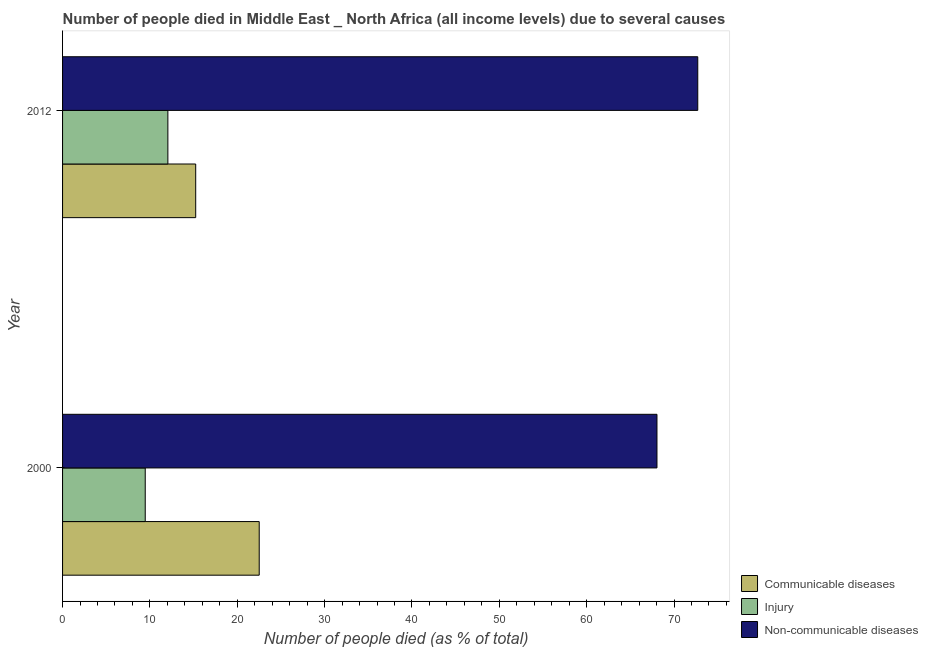How many groups of bars are there?
Make the answer very short. 2. How many bars are there on the 2nd tick from the top?
Offer a very short reply. 3. In how many cases, is the number of bars for a given year not equal to the number of legend labels?
Provide a succinct answer. 0. What is the number of people who died of communicable diseases in 2012?
Ensure brevity in your answer.  15.24. Across all years, what is the maximum number of people who dies of non-communicable diseases?
Keep it short and to the point. 72.72. Across all years, what is the minimum number of people who dies of non-communicable diseases?
Provide a succinct answer. 68.05. In which year was the number of people who dies of non-communicable diseases maximum?
Give a very brief answer. 2012. In which year was the number of people who died of injury minimum?
Make the answer very short. 2000. What is the total number of people who died of injury in the graph?
Provide a short and direct response. 21.52. What is the difference between the number of people who dies of non-communicable diseases in 2000 and that in 2012?
Give a very brief answer. -4.67. What is the difference between the number of people who died of injury in 2000 and the number of people who dies of non-communicable diseases in 2012?
Offer a terse response. -63.25. What is the average number of people who dies of non-communicable diseases per year?
Make the answer very short. 70.38. In the year 2000, what is the difference between the number of people who dies of non-communicable diseases and number of people who died of communicable diseases?
Keep it short and to the point. 45.53. In how many years, is the number of people who died of communicable diseases greater than 62 %?
Your answer should be compact. 0. What is the ratio of the number of people who dies of non-communicable diseases in 2000 to that in 2012?
Make the answer very short. 0.94. Is the number of people who dies of non-communicable diseases in 2000 less than that in 2012?
Your answer should be very brief. Yes. What does the 1st bar from the top in 2012 represents?
Make the answer very short. Non-communicable diseases. What does the 2nd bar from the bottom in 2012 represents?
Keep it short and to the point. Injury. How many years are there in the graph?
Offer a very short reply. 2. Are the values on the major ticks of X-axis written in scientific E-notation?
Give a very brief answer. No. Does the graph contain grids?
Keep it short and to the point. No. Where does the legend appear in the graph?
Give a very brief answer. Bottom right. How many legend labels are there?
Give a very brief answer. 3. How are the legend labels stacked?
Provide a succinct answer. Vertical. What is the title of the graph?
Your response must be concise. Number of people died in Middle East _ North Africa (all income levels) due to several causes. Does "Tertiary" appear as one of the legend labels in the graph?
Make the answer very short. No. What is the label or title of the X-axis?
Ensure brevity in your answer.  Number of people died (as % of total). What is the Number of people died (as % of total) of Communicable diseases in 2000?
Give a very brief answer. 22.51. What is the Number of people died (as % of total) of Injury in 2000?
Ensure brevity in your answer.  9.46. What is the Number of people died (as % of total) of Non-communicable diseases in 2000?
Your response must be concise. 68.05. What is the Number of people died (as % of total) of Communicable diseases in 2012?
Ensure brevity in your answer.  15.24. What is the Number of people died (as % of total) of Injury in 2012?
Make the answer very short. 12.06. What is the Number of people died (as % of total) in Non-communicable diseases in 2012?
Your response must be concise. 72.72. Across all years, what is the maximum Number of people died (as % of total) of Communicable diseases?
Ensure brevity in your answer.  22.51. Across all years, what is the maximum Number of people died (as % of total) of Injury?
Provide a short and direct response. 12.06. Across all years, what is the maximum Number of people died (as % of total) in Non-communicable diseases?
Your answer should be very brief. 72.72. Across all years, what is the minimum Number of people died (as % of total) in Communicable diseases?
Keep it short and to the point. 15.24. Across all years, what is the minimum Number of people died (as % of total) in Injury?
Provide a succinct answer. 9.46. Across all years, what is the minimum Number of people died (as % of total) in Non-communicable diseases?
Ensure brevity in your answer.  68.05. What is the total Number of people died (as % of total) in Communicable diseases in the graph?
Provide a succinct answer. 37.75. What is the total Number of people died (as % of total) of Injury in the graph?
Offer a terse response. 21.52. What is the total Number of people died (as % of total) of Non-communicable diseases in the graph?
Give a very brief answer. 140.76. What is the difference between the Number of people died (as % of total) of Communicable diseases in 2000 and that in 2012?
Your answer should be very brief. 7.27. What is the difference between the Number of people died (as % of total) in Injury in 2000 and that in 2012?
Your answer should be compact. -2.59. What is the difference between the Number of people died (as % of total) of Non-communicable diseases in 2000 and that in 2012?
Ensure brevity in your answer.  -4.67. What is the difference between the Number of people died (as % of total) in Communicable diseases in 2000 and the Number of people died (as % of total) in Injury in 2012?
Provide a short and direct response. 10.46. What is the difference between the Number of people died (as % of total) of Communicable diseases in 2000 and the Number of people died (as % of total) of Non-communicable diseases in 2012?
Your answer should be compact. -50.2. What is the difference between the Number of people died (as % of total) of Injury in 2000 and the Number of people died (as % of total) of Non-communicable diseases in 2012?
Ensure brevity in your answer.  -63.25. What is the average Number of people died (as % of total) of Communicable diseases per year?
Ensure brevity in your answer.  18.88. What is the average Number of people died (as % of total) of Injury per year?
Offer a terse response. 10.76. What is the average Number of people died (as % of total) of Non-communicable diseases per year?
Offer a very short reply. 70.38. In the year 2000, what is the difference between the Number of people died (as % of total) in Communicable diseases and Number of people died (as % of total) in Injury?
Provide a succinct answer. 13.05. In the year 2000, what is the difference between the Number of people died (as % of total) of Communicable diseases and Number of people died (as % of total) of Non-communicable diseases?
Your answer should be compact. -45.53. In the year 2000, what is the difference between the Number of people died (as % of total) of Injury and Number of people died (as % of total) of Non-communicable diseases?
Provide a short and direct response. -58.58. In the year 2012, what is the difference between the Number of people died (as % of total) of Communicable diseases and Number of people died (as % of total) of Injury?
Your response must be concise. 3.19. In the year 2012, what is the difference between the Number of people died (as % of total) in Communicable diseases and Number of people died (as % of total) in Non-communicable diseases?
Ensure brevity in your answer.  -57.48. In the year 2012, what is the difference between the Number of people died (as % of total) of Injury and Number of people died (as % of total) of Non-communicable diseases?
Offer a terse response. -60.66. What is the ratio of the Number of people died (as % of total) in Communicable diseases in 2000 to that in 2012?
Ensure brevity in your answer.  1.48. What is the ratio of the Number of people died (as % of total) in Injury in 2000 to that in 2012?
Provide a short and direct response. 0.79. What is the ratio of the Number of people died (as % of total) in Non-communicable diseases in 2000 to that in 2012?
Offer a terse response. 0.94. What is the difference between the highest and the second highest Number of people died (as % of total) in Communicable diseases?
Your response must be concise. 7.27. What is the difference between the highest and the second highest Number of people died (as % of total) in Injury?
Offer a terse response. 2.59. What is the difference between the highest and the second highest Number of people died (as % of total) of Non-communicable diseases?
Offer a very short reply. 4.67. What is the difference between the highest and the lowest Number of people died (as % of total) in Communicable diseases?
Keep it short and to the point. 7.27. What is the difference between the highest and the lowest Number of people died (as % of total) in Injury?
Offer a terse response. 2.59. What is the difference between the highest and the lowest Number of people died (as % of total) of Non-communicable diseases?
Offer a very short reply. 4.67. 